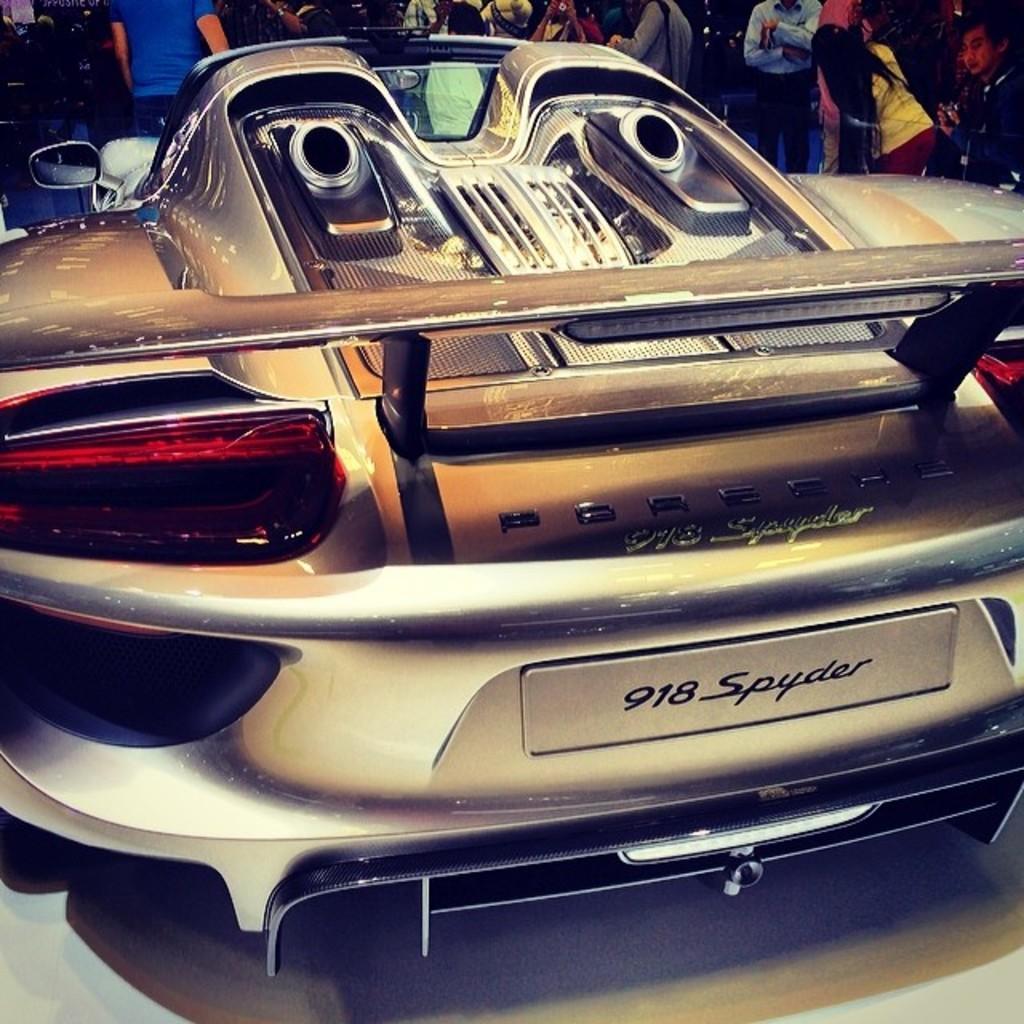How would you summarize this image in a sentence or two? Here in this picture we can see a car present on the floor over there and in front of it we can see number of people standing over there. 